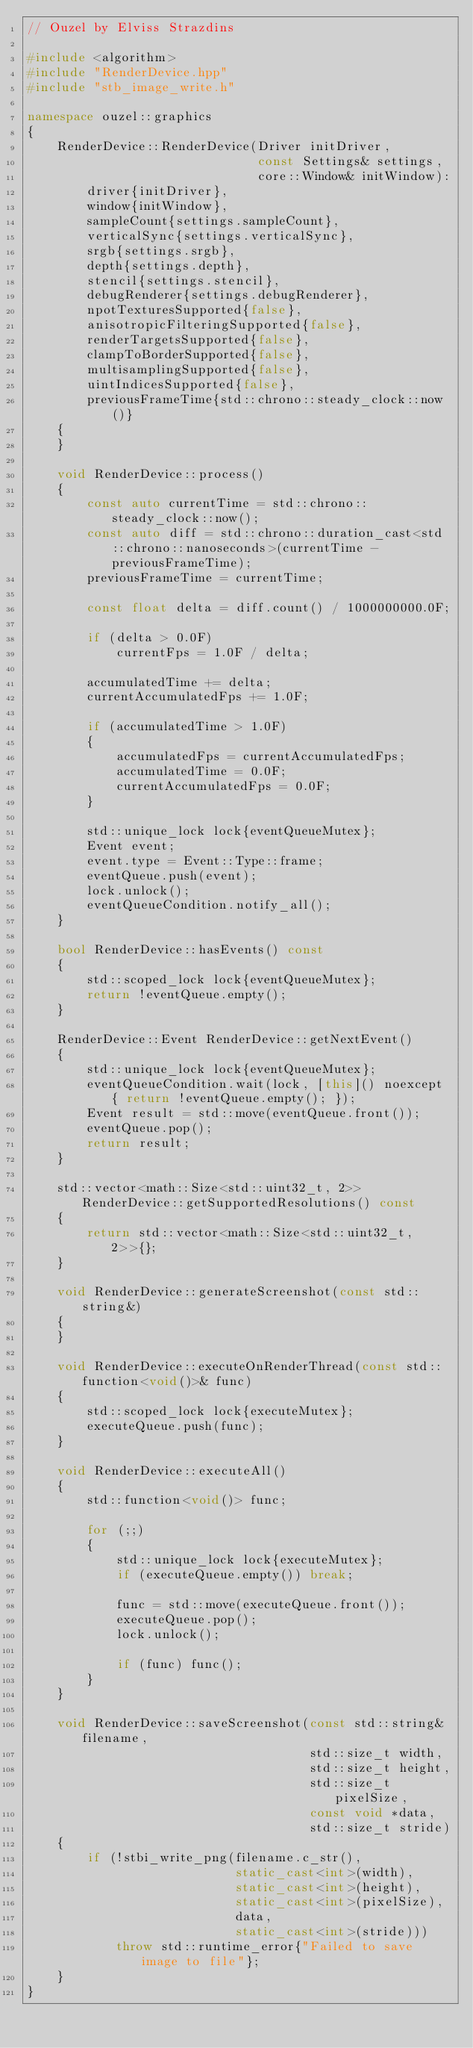<code> <loc_0><loc_0><loc_500><loc_500><_C++_>// Ouzel by Elviss Strazdins

#include <algorithm>
#include "RenderDevice.hpp"
#include "stb_image_write.h"

namespace ouzel::graphics
{
    RenderDevice::RenderDevice(Driver initDriver,
                               const Settings& settings,
                               core::Window& initWindow):
        driver{initDriver},
        window{initWindow},
        sampleCount{settings.sampleCount},
        verticalSync{settings.verticalSync},
        srgb{settings.srgb},
        depth{settings.depth},
        stencil{settings.stencil},
        debugRenderer{settings.debugRenderer},
        npotTexturesSupported{false},
        anisotropicFilteringSupported{false},
        renderTargetsSupported{false},
        clampToBorderSupported{false},
        multisamplingSupported{false},
        uintIndicesSupported{false},
        previousFrameTime{std::chrono::steady_clock::now()}
    {
    }

    void RenderDevice::process()
    {
        const auto currentTime = std::chrono::steady_clock::now();
        const auto diff = std::chrono::duration_cast<std::chrono::nanoseconds>(currentTime - previousFrameTime);
        previousFrameTime = currentTime;

        const float delta = diff.count() / 1000000000.0F;

        if (delta > 0.0F)
            currentFps = 1.0F / delta;

        accumulatedTime += delta;
        currentAccumulatedFps += 1.0F;

        if (accumulatedTime > 1.0F)
        {
            accumulatedFps = currentAccumulatedFps;
            accumulatedTime = 0.0F;
            currentAccumulatedFps = 0.0F;
        }

        std::unique_lock lock{eventQueueMutex};
        Event event;
        event.type = Event::Type::frame;
        eventQueue.push(event);
        lock.unlock();
        eventQueueCondition.notify_all();
    }

    bool RenderDevice::hasEvents() const
    {
        std::scoped_lock lock{eventQueueMutex};
        return !eventQueue.empty();
    }

    RenderDevice::Event RenderDevice::getNextEvent()
    {
        std::unique_lock lock{eventQueueMutex};
        eventQueueCondition.wait(lock, [this]() noexcept { return !eventQueue.empty(); });
        Event result = std::move(eventQueue.front());
        eventQueue.pop();
        return result;
    }

    std::vector<math::Size<std::uint32_t, 2>> RenderDevice::getSupportedResolutions() const
    {
        return std::vector<math::Size<std::uint32_t, 2>>{};
    }

    void RenderDevice::generateScreenshot(const std::string&)
    {
    }

    void RenderDevice::executeOnRenderThread(const std::function<void()>& func)
    {
        std::scoped_lock lock{executeMutex};
        executeQueue.push(func);
    }

    void RenderDevice::executeAll()
    {
        std::function<void()> func;

        for (;;)
        {
            std::unique_lock lock{executeMutex};
            if (executeQueue.empty()) break;

            func = std::move(executeQueue.front());
            executeQueue.pop();
            lock.unlock();

            if (func) func();
        }
    }

    void RenderDevice::saveScreenshot(const std::string& filename,
                                      std::size_t width,
                                      std::size_t height,
                                      std::size_t pixelSize,
                                      const void *data,
                                      std::size_t stride)
    {
        if (!stbi_write_png(filename.c_str(),
                            static_cast<int>(width),
                            static_cast<int>(height),
                            static_cast<int>(pixelSize),
                            data,
                            static_cast<int>(stride)))
            throw std::runtime_error{"Failed to save image to file"};
    }
}
</code> 